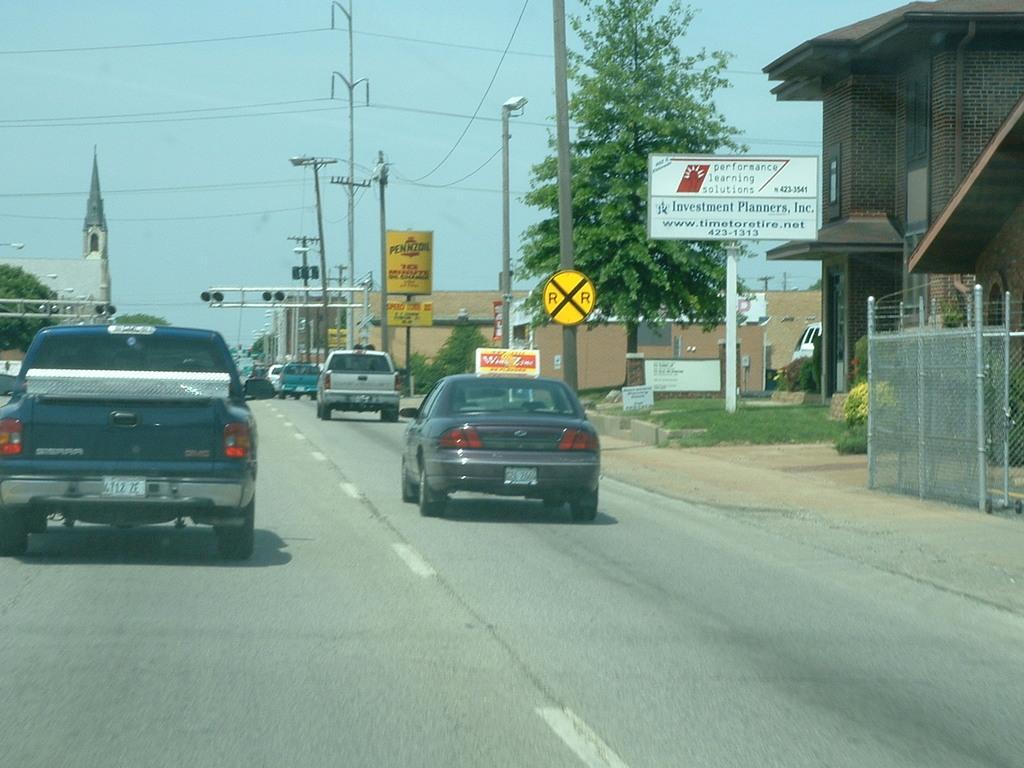Could you give a brief overview of what you see in this image? In this picture we can see vehicles on the road, name boards, posters, poles, lights, buildings, plants, grass, fence, trees, wires and some objects and in the background we can see the sky. 